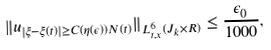<formula> <loc_0><loc_0><loc_500><loc_500>\| u _ { | \xi - \xi ( t ) | \geq C ( \eta ( \epsilon ) ) N ( t ) } \| _ { L _ { t , x } ^ { 6 } ( J _ { k } \times R ) } \leq \frac { \epsilon _ { 0 } } { 1 0 0 0 } ,</formula> 